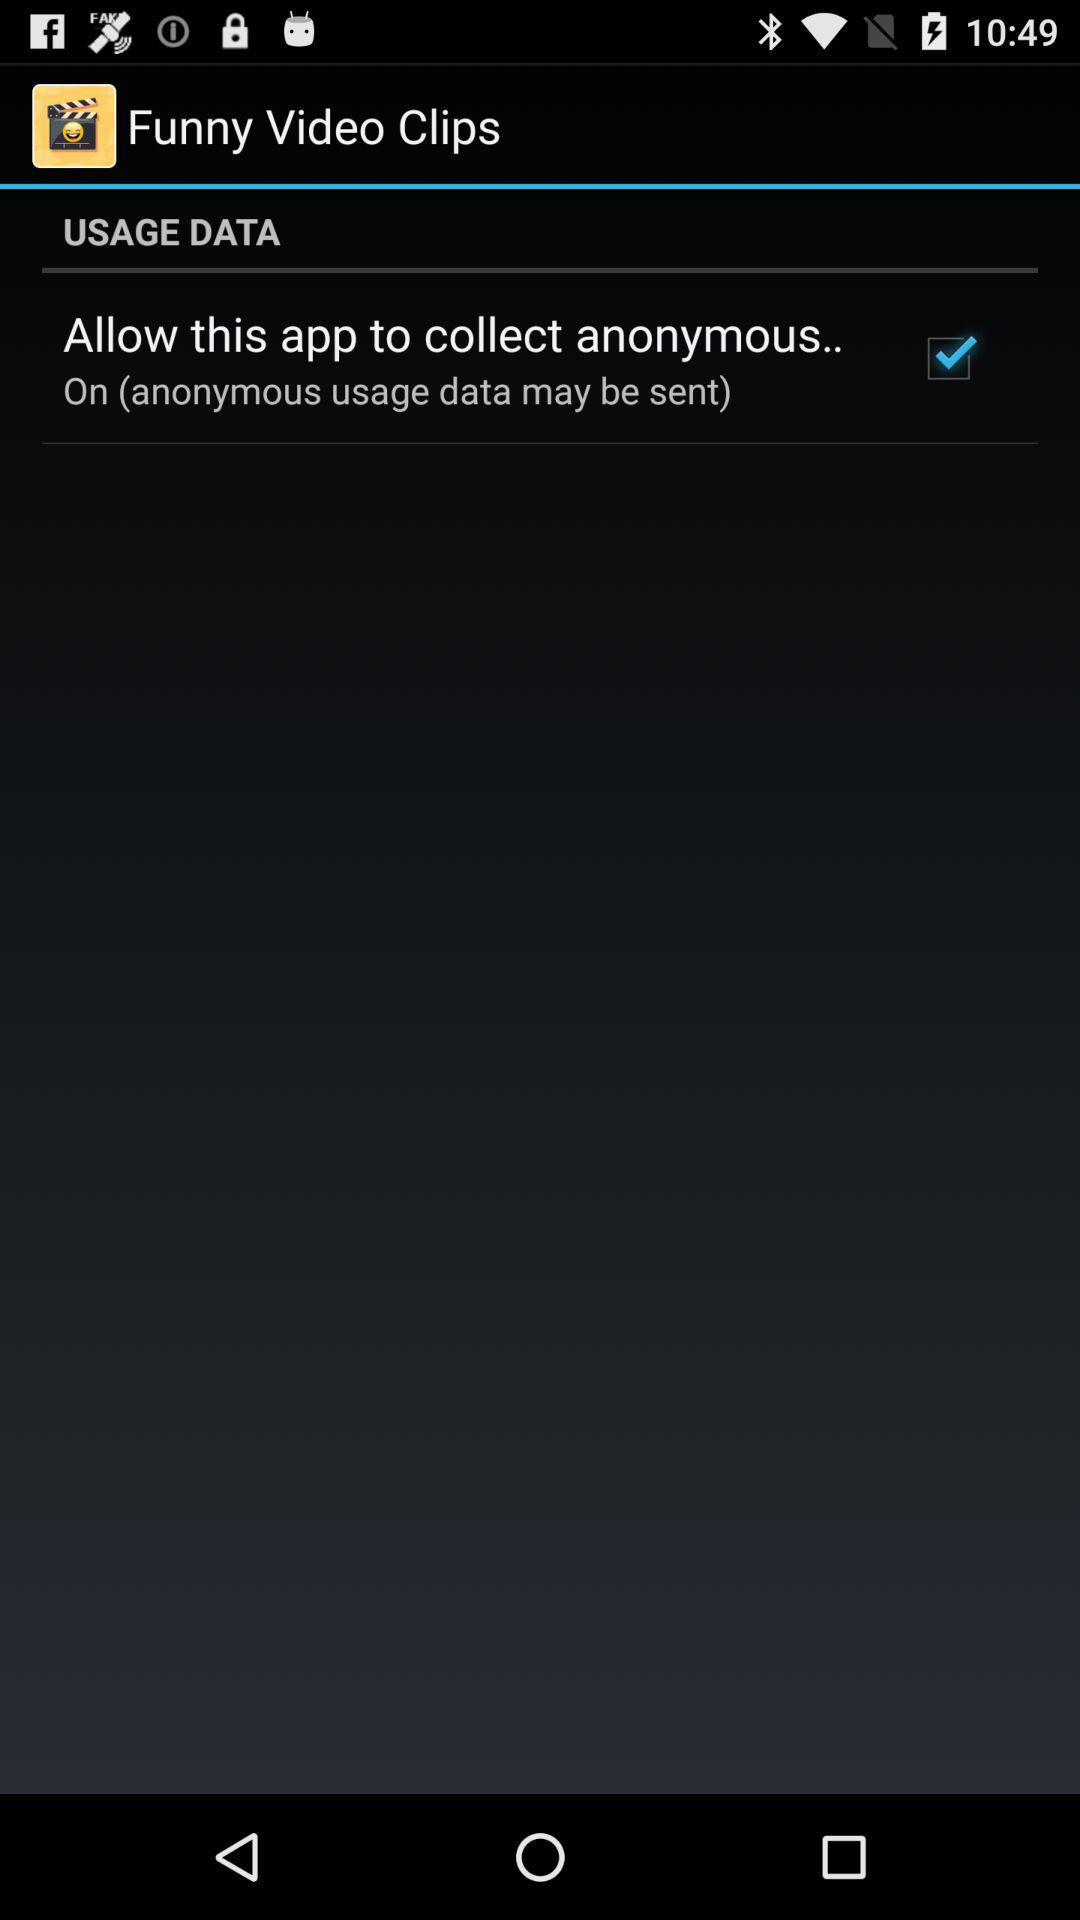What is the name of the application? The name of the application is "Funny Video Clips". 